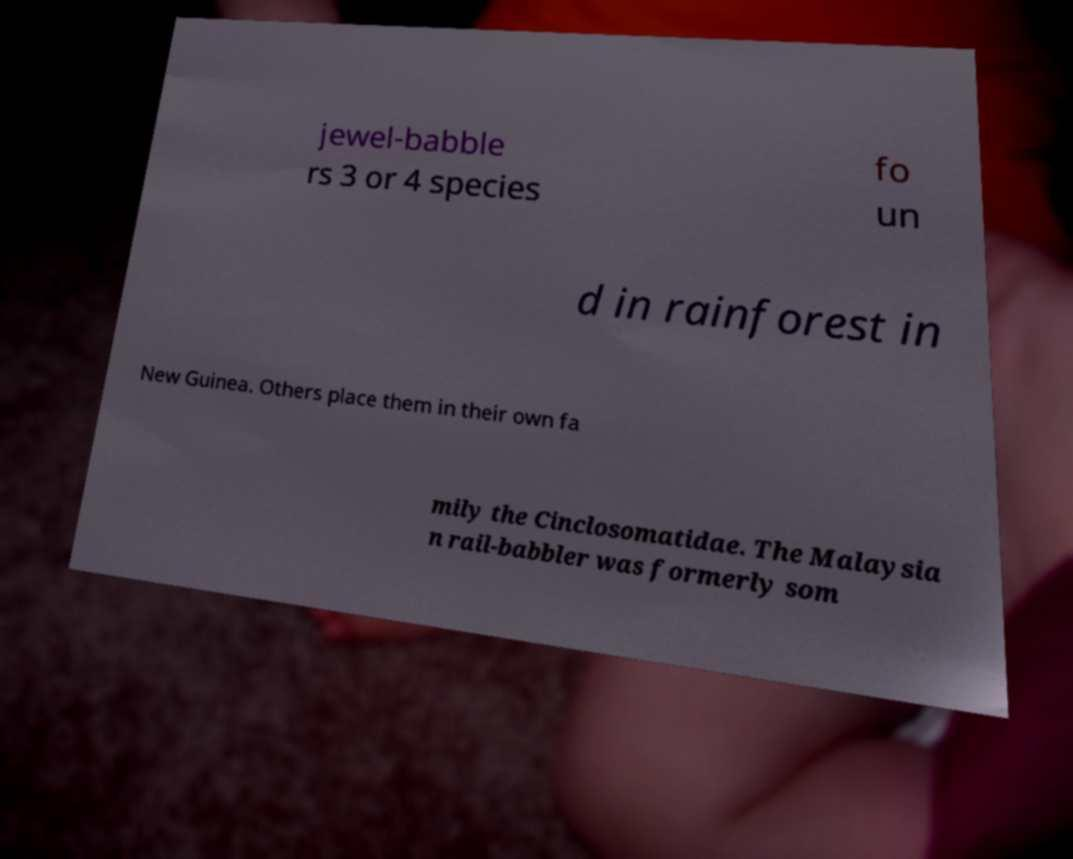There's text embedded in this image that I need extracted. Can you transcribe it verbatim? jewel-babble rs 3 or 4 species fo un d in rainforest in New Guinea. Others place them in their own fa mily the Cinclosomatidae. The Malaysia n rail-babbler was formerly som 